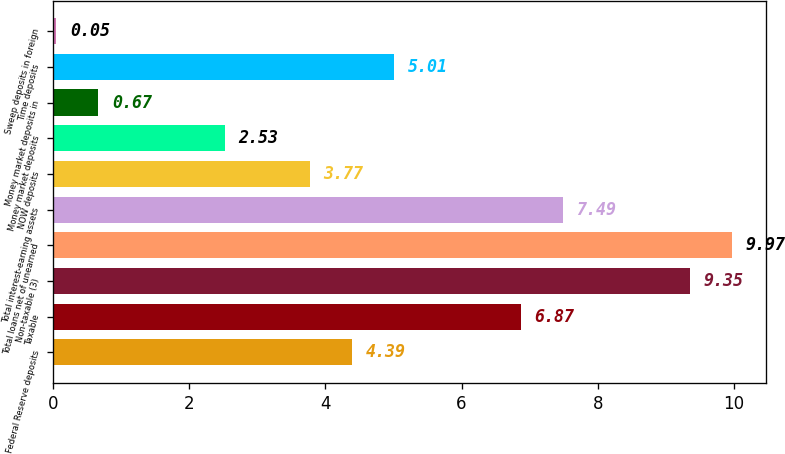Convert chart to OTSL. <chart><loc_0><loc_0><loc_500><loc_500><bar_chart><fcel>Federal Reserve deposits<fcel>Taxable<fcel>Non-taxable (3)<fcel>Total loans net of unearned<fcel>Total interest-earning assets<fcel>NOW deposits<fcel>Money market deposits<fcel>Money market deposits in<fcel>Time deposits<fcel>Sweep deposits in foreign<nl><fcel>4.39<fcel>6.87<fcel>9.35<fcel>9.97<fcel>7.49<fcel>3.77<fcel>2.53<fcel>0.67<fcel>5.01<fcel>0.05<nl></chart> 